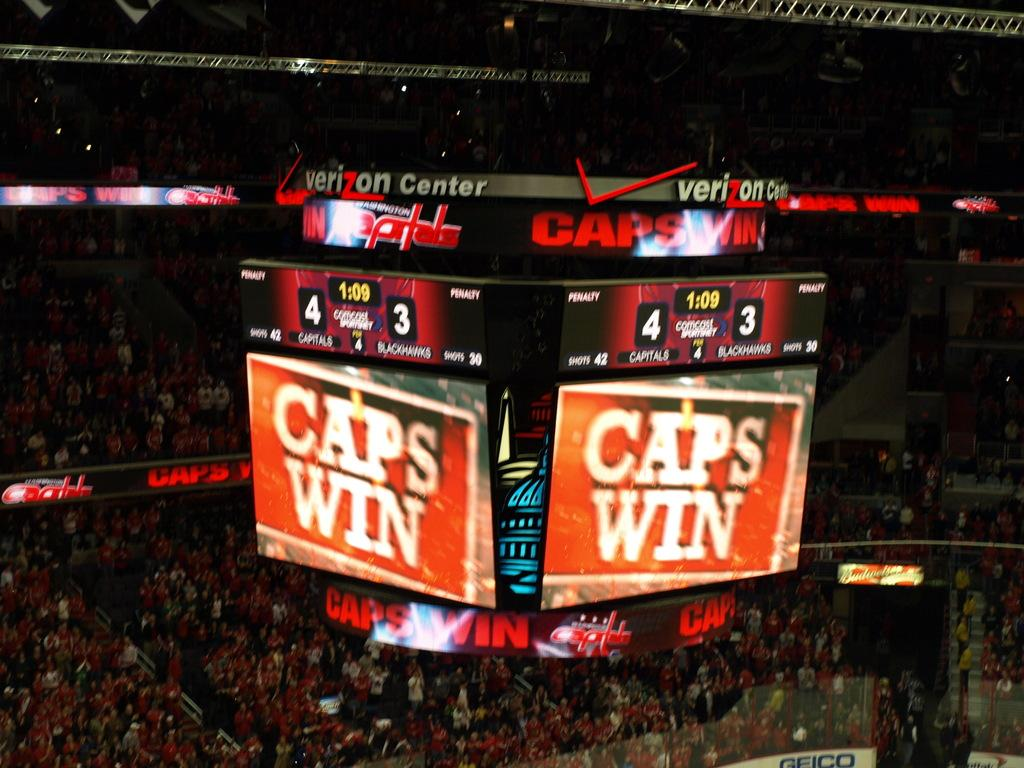<image>
Relay a brief, clear account of the picture shown. The scoreboard of the Verizon center with the slogan 'Caps Win' 